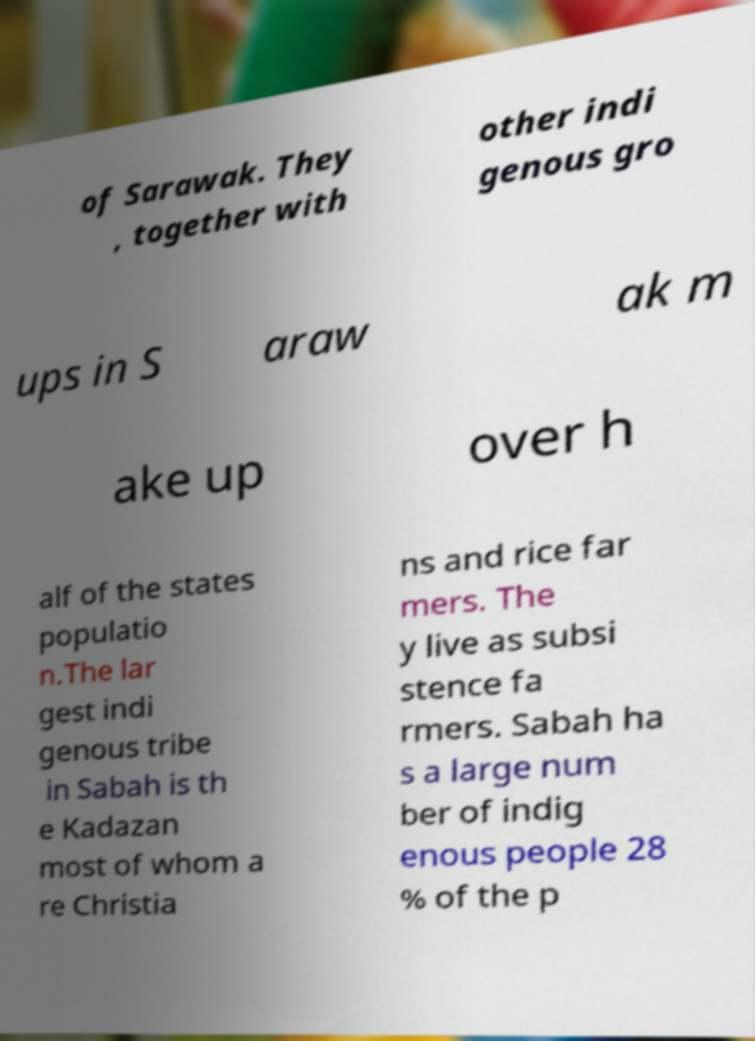Can you read and provide the text displayed in the image?This photo seems to have some interesting text. Can you extract and type it out for me? of Sarawak. They , together with other indi genous gro ups in S araw ak m ake up over h alf of the states populatio n.The lar gest indi genous tribe in Sabah is th e Kadazan most of whom a re Christia ns and rice far mers. The y live as subsi stence fa rmers. Sabah ha s a large num ber of indig enous people 28 % of the p 